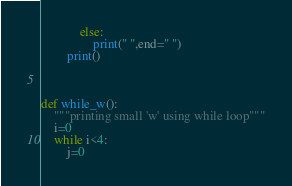Convert code to text. <code><loc_0><loc_0><loc_500><loc_500><_Python_>            else:
                print(" ",end=" ")
        print()



def while_w():
    """printing small 'w' using while loop"""
    i=0
    while i<4:
        j=0</code> 